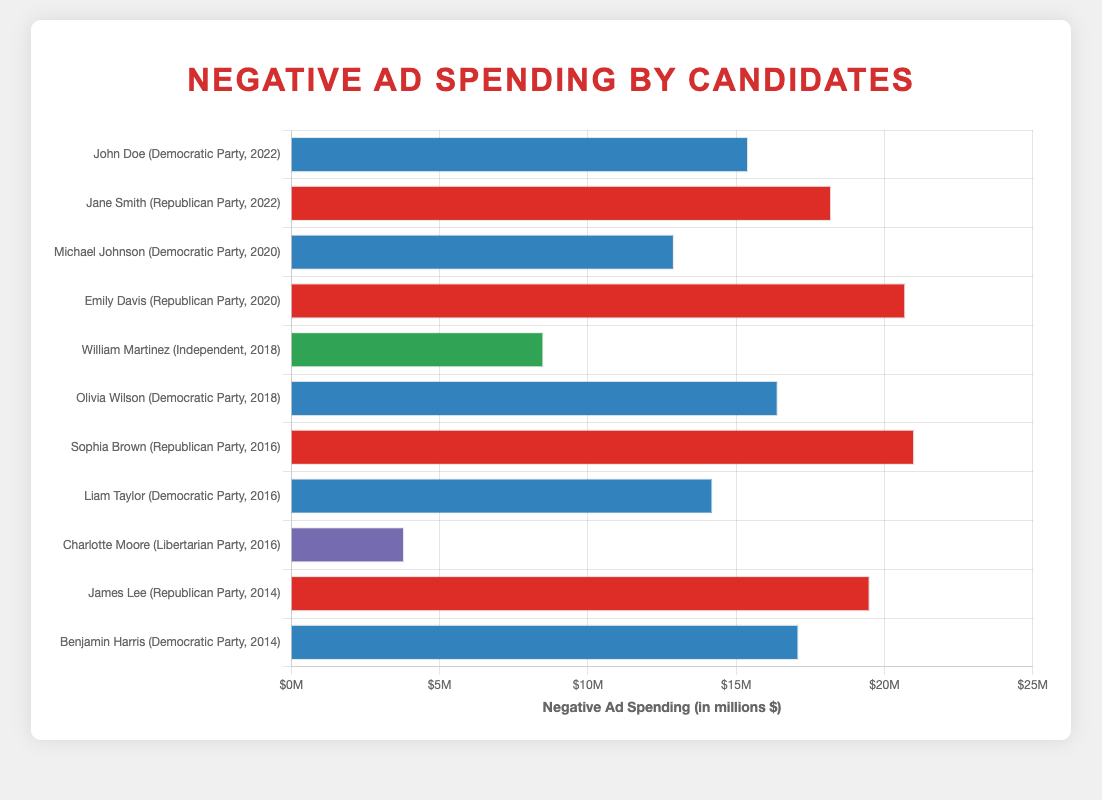Which candidate had the highest negative ad spending overall? Sophia Brown had the highest negative ad spending overall. This is seen from the horizontal bar chart where Sophia Brown's bar is the longest, indicating the highest spending amount of 21.0 million dollars.
Answer: Sophia Brown Who spent more on negative ads in the 2020 election, Michael Johnson or Emily Davis? Emily Davis spent more on negative ads. Comparing the bar lengths for 2020, Emily Davis's bar is longer with 20.7 million dollars compared to Michael Johnson's 12.9 million dollars.
Answer: Emily Davis What is the difference in negative ad spending between Jane Smith and John Doe in the 2022 election? Jane Smith spent 18.2 million dollars, and John Doe spent 15.4 million dollars. The difference is 18.2 - 15.4 = 2.8 million dollars.
Answer: 2.8 million dollars Which party had the overall highest single instance of negative ad spending? The Republican Party had the highest single instance of negative ad spending with Sophia Brown's 21.0 million dollars in 2016. This is the longest bar in the chart.
Answer: Republican Party What's the average negative ad spending by Democratic Party candidates listed in the data? The Democratic Party candidates listed are John Doe (15.4), Michael Johnson (12.9), Olivia Wilson (16.4), Liam Taylor (14.2), and Benjamin Harris (17.1). Sum: 15.4 + 12.9 + 16.4 + 14.2 + 17.1 = 76. Total candidates: 5. Average = 76/5 = 15.2 million dollars.
Answer: 15.2 million dollars 